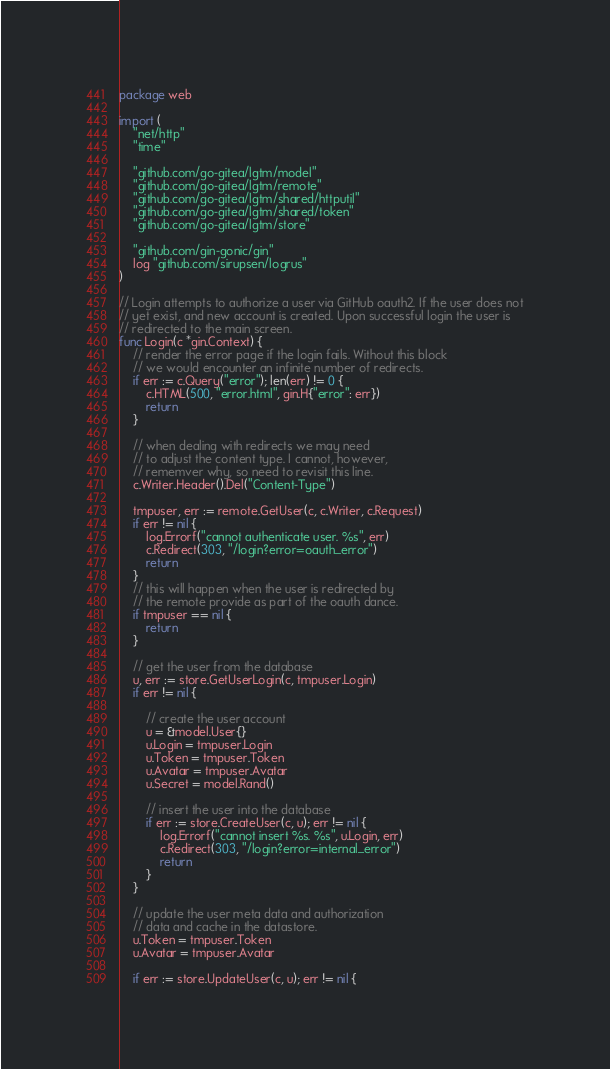Convert code to text. <code><loc_0><loc_0><loc_500><loc_500><_Go_>package web

import (
	"net/http"
	"time"

	"github.com/go-gitea/lgtm/model"
	"github.com/go-gitea/lgtm/remote"
	"github.com/go-gitea/lgtm/shared/httputil"
	"github.com/go-gitea/lgtm/shared/token"
	"github.com/go-gitea/lgtm/store"

	"github.com/gin-gonic/gin"
	log "github.com/sirupsen/logrus"
)

// Login attempts to authorize a user via GitHub oauth2. If the user does not
// yet exist, and new account is created. Upon successful login the user is
// redirected to the main screen.
func Login(c *gin.Context) {
	// render the error page if the login fails. Without this block
	// we would encounter an infinite number of redirects.
	if err := c.Query("error"); len(err) != 0 {
		c.HTML(500, "error.html", gin.H{"error": err})
		return
	}

	// when dealing with redirects we may need
	// to adjust the content type. I cannot, however,
	// rememver why, so need to revisit this line.
	c.Writer.Header().Del("Content-Type")

	tmpuser, err := remote.GetUser(c, c.Writer, c.Request)
	if err != nil {
		log.Errorf("cannot authenticate user. %s", err)
		c.Redirect(303, "/login?error=oauth_error")
		return
	}
	// this will happen when the user is redirected by
	// the remote provide as part of the oauth dance.
	if tmpuser == nil {
		return
	}

	// get the user from the database
	u, err := store.GetUserLogin(c, tmpuser.Login)
	if err != nil {

		// create the user account
		u = &model.User{}
		u.Login = tmpuser.Login
		u.Token = tmpuser.Token
		u.Avatar = tmpuser.Avatar
		u.Secret = model.Rand()

		// insert the user into the database
		if err := store.CreateUser(c, u); err != nil {
			log.Errorf("cannot insert %s. %s", u.Login, err)
			c.Redirect(303, "/login?error=internal_error")
			return
		}
	}

	// update the user meta data and authorization
	// data and cache in the datastore.
	u.Token = tmpuser.Token
	u.Avatar = tmpuser.Avatar

	if err := store.UpdateUser(c, u); err != nil {</code> 